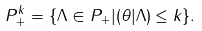<formula> <loc_0><loc_0><loc_500><loc_500>P _ { + } ^ { k } = \{ \Lambda \in P _ { + } | ( \theta | \Lambda ) \leq k \} .</formula> 